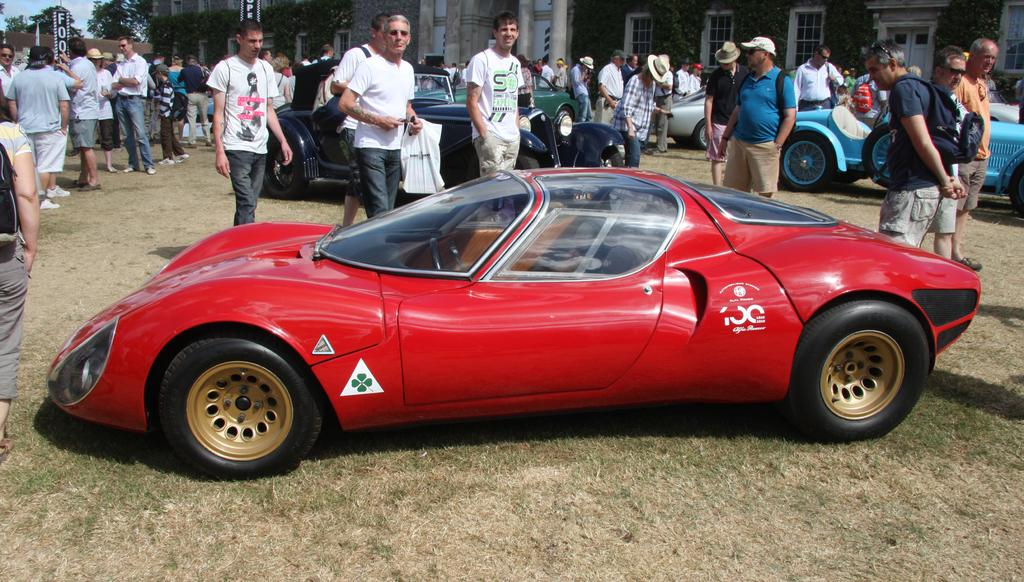What color is the car that is visible in the image? There is a red car in the image. What type of vegetation is present at the bottom of the image? Dry grass is present at the bottom of the image. What can be seen in the background of the image? There are many cars in the background of the image. Are there any people in the image? Yes, there are people in the image. What type of reward is being handed out to the people in the image? There is no indication of a reward being handed out in the image. 